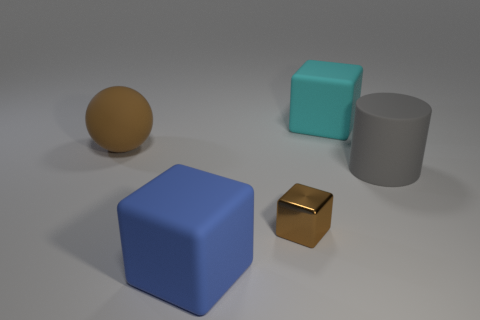What kind of lighting is present in the image, and what time of day does it resemble? The lighting in the image is soft and diffused, casting gentle shadows on the ground. This could resemble indoor lighting or an overcast day, where the sun is hidden behind clouds resulting in a lack of harsh shadows. 